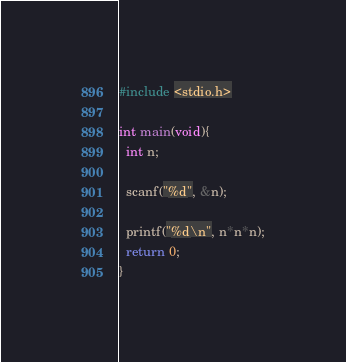<code> <loc_0><loc_0><loc_500><loc_500><_C_>#include <stdio.h>

int main(void){
  int n;

  scanf("%d", &n);

  printf("%d\n", n*n*n);
  return 0;
}</code> 